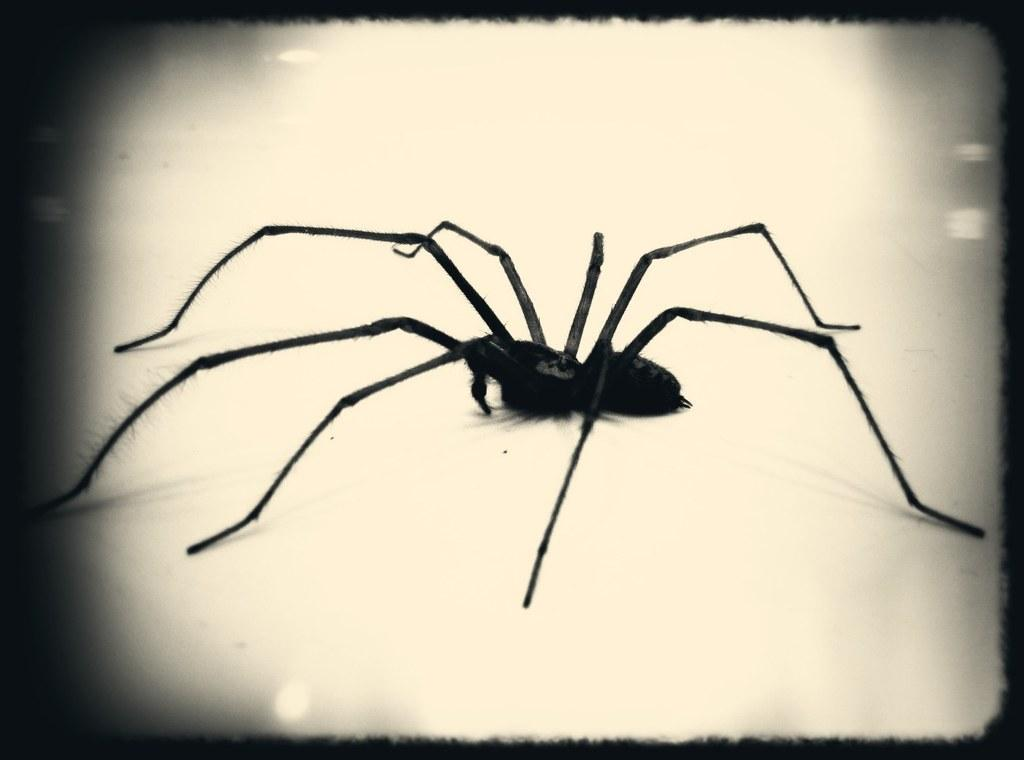What is the main subject of the image? There is a spider in the image. What color is the spider? The spider is black in color. What type of fruit is hanging from the spider's tail in the image? There is no fruit or tail present on the spider in the image. 